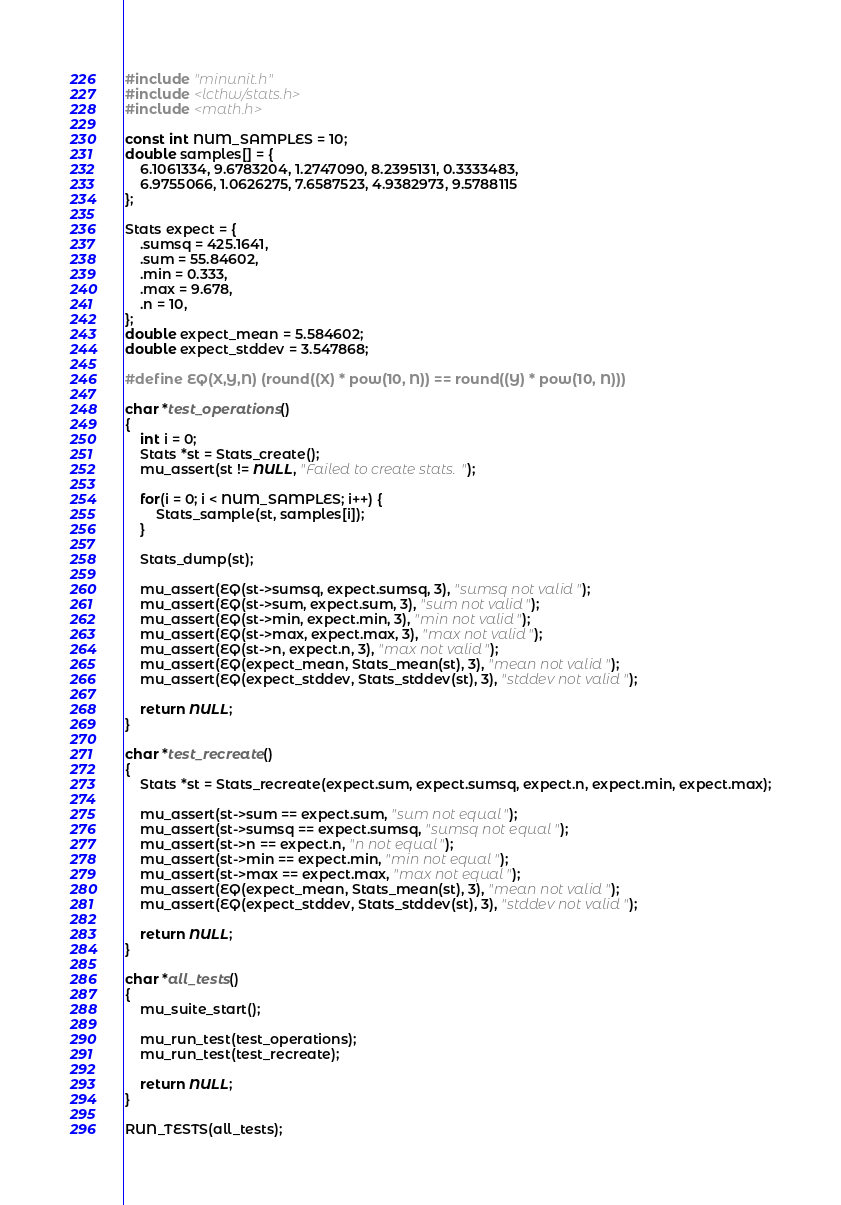<code> <loc_0><loc_0><loc_500><loc_500><_C_>#include "minunit.h"
#include <lcthw/stats.h>
#include <math.h>

const int NUM_SAMPLES = 10;
double samples[] = {
    6.1061334, 9.6783204, 1.2747090, 8.2395131, 0.3333483,
    6.9755066, 1.0626275, 7.6587523, 4.9382973, 9.5788115
};

Stats expect = {
    .sumsq = 425.1641,
    .sum = 55.84602,
    .min = 0.333,
    .max = 9.678,
    .n = 10,
};
double expect_mean = 5.584602;
double expect_stddev = 3.547868;

#define EQ(X,Y,N) (round((X) * pow(10, N)) == round((Y) * pow(10, N)))

char *test_operations()
{
    int i = 0;
    Stats *st = Stats_create();
    mu_assert(st != NULL, "Failed to create stats.");

    for(i = 0; i < NUM_SAMPLES; i++) {
        Stats_sample(st, samples[i]);
    }

    Stats_dump(st);

    mu_assert(EQ(st->sumsq, expect.sumsq, 3), "sumsq not valid");
    mu_assert(EQ(st->sum, expect.sum, 3), "sum not valid");
    mu_assert(EQ(st->min, expect.min, 3), "min not valid");
    mu_assert(EQ(st->max, expect.max, 3), "max not valid");
    mu_assert(EQ(st->n, expect.n, 3), "max not valid");
    mu_assert(EQ(expect_mean, Stats_mean(st), 3), "mean not valid");
    mu_assert(EQ(expect_stddev, Stats_stddev(st), 3), "stddev not valid");

    return NULL;
}

char *test_recreate()
{
    Stats *st = Stats_recreate(expect.sum, expect.sumsq, expect.n, expect.min, expect.max);

    mu_assert(st->sum == expect.sum, "sum not equal");
    mu_assert(st->sumsq == expect.sumsq, "sumsq not equal");
    mu_assert(st->n == expect.n, "n not equal");
    mu_assert(st->min == expect.min, "min not equal");
    mu_assert(st->max == expect.max, "max not equal");
    mu_assert(EQ(expect_mean, Stats_mean(st), 3), "mean not valid");
    mu_assert(EQ(expect_stddev, Stats_stddev(st), 3), "stddev not valid");

    return NULL;
}

char *all_tests()
{
    mu_suite_start();

    mu_run_test(test_operations);
    mu_run_test(test_recreate);

    return NULL;
}

RUN_TESTS(all_tests);
</code> 